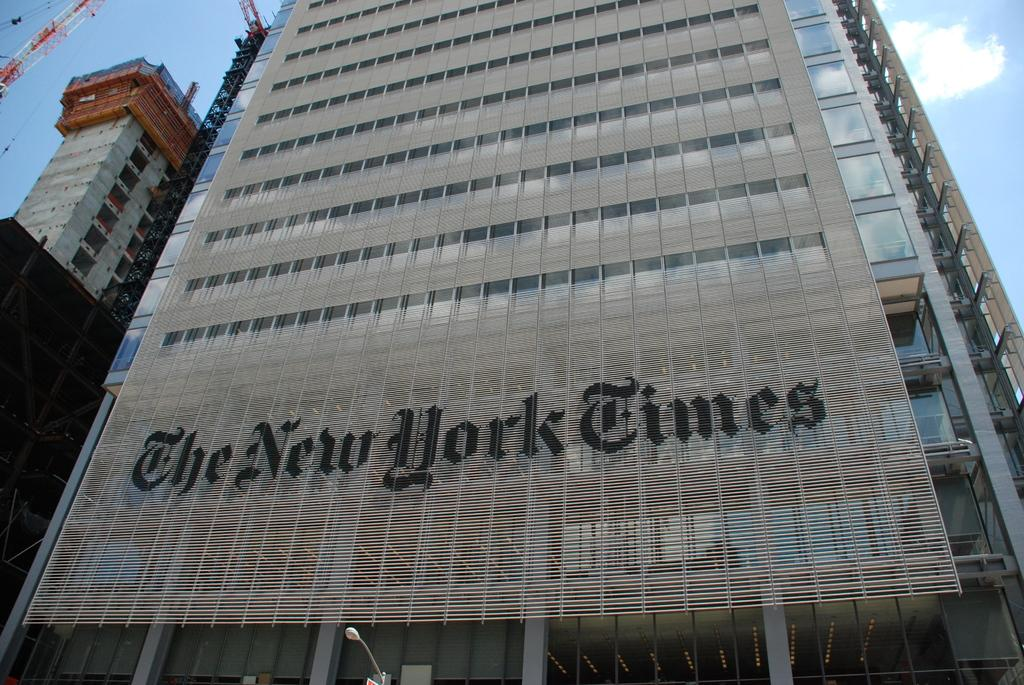What type of structures can be seen in the image? There are buildings in the image. What is the color of the crane in the image? The crane in the image is red. What else is visible in the image besides the buildings and crane? There is text visible in the image. What can be seen in the background of the image? There are clouds and the sky visible in the background of the image. What advice does the mother give to her child in the image? There is no mother or child present in the image, so it is not possible to answer that question. 